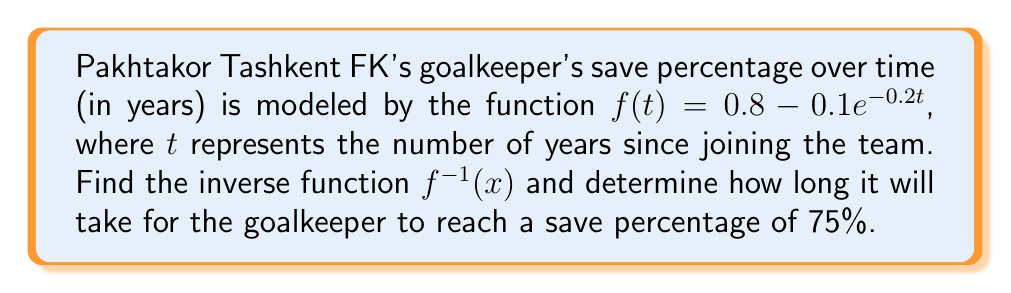What is the answer to this math problem? 1) To find the inverse function, we first replace $f(t)$ with $x$:

   $x = 0.8 - 0.1e^{-0.2t}$

2) Subtract 0.8 from both sides:

   $x - 0.8 = -0.1e^{-0.2t}$

3) Divide both sides by -0.1:

   $\frac{0.8 - x}{0.1} = e^{-0.2t}$

4) Take the natural logarithm of both sides:

   $\ln(\frac{0.8 - x}{0.1}) = -0.2t$

5) Divide both sides by -0.2:

   $-5\ln(\frac{0.8 - x}{0.1}) = t$

6) Therefore, the inverse function is:

   $f^{-1}(x) = -5\ln(\frac{0.8 - x}{0.1})$

7) To find how long it takes to reach a 75% save percentage, we substitute $x = 0.75$ into $f^{-1}(x)$:

   $f^{-1}(0.75) = -5\ln(\frac{0.8 - 0.75}{0.1}) = -5\ln(0.5) \approx 3.47$ years
Answer: $f^{-1}(x) = -5\ln(\frac{0.8 - x}{0.1})$; approximately 3.47 years 